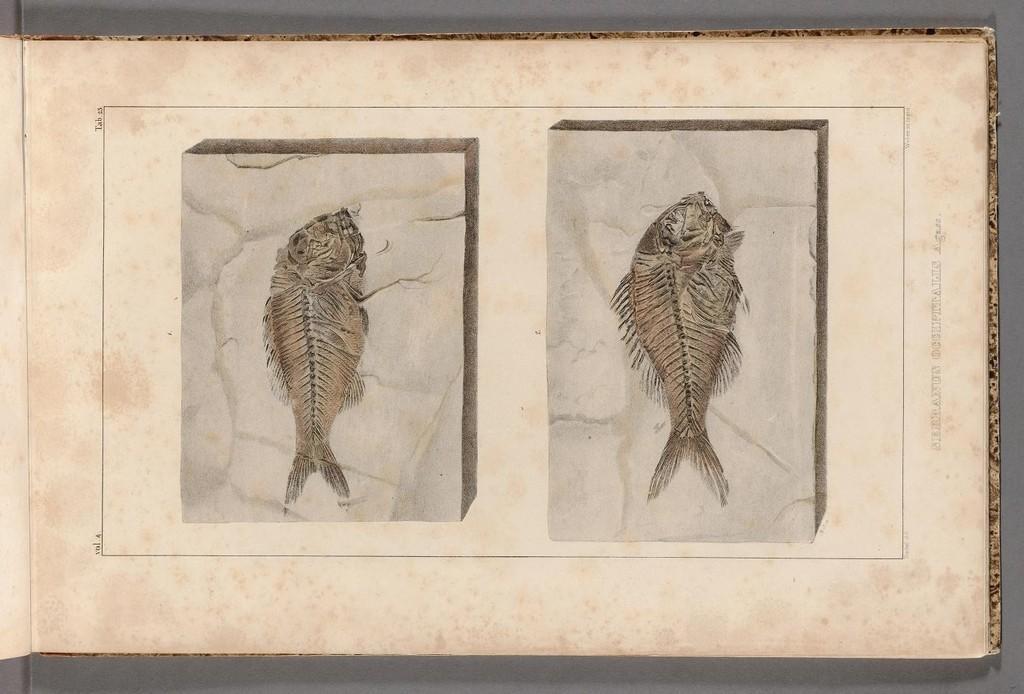Please provide a concise description of this image. In the center of the image there is a sheet and we can see pictures of fishes on the sheet. 